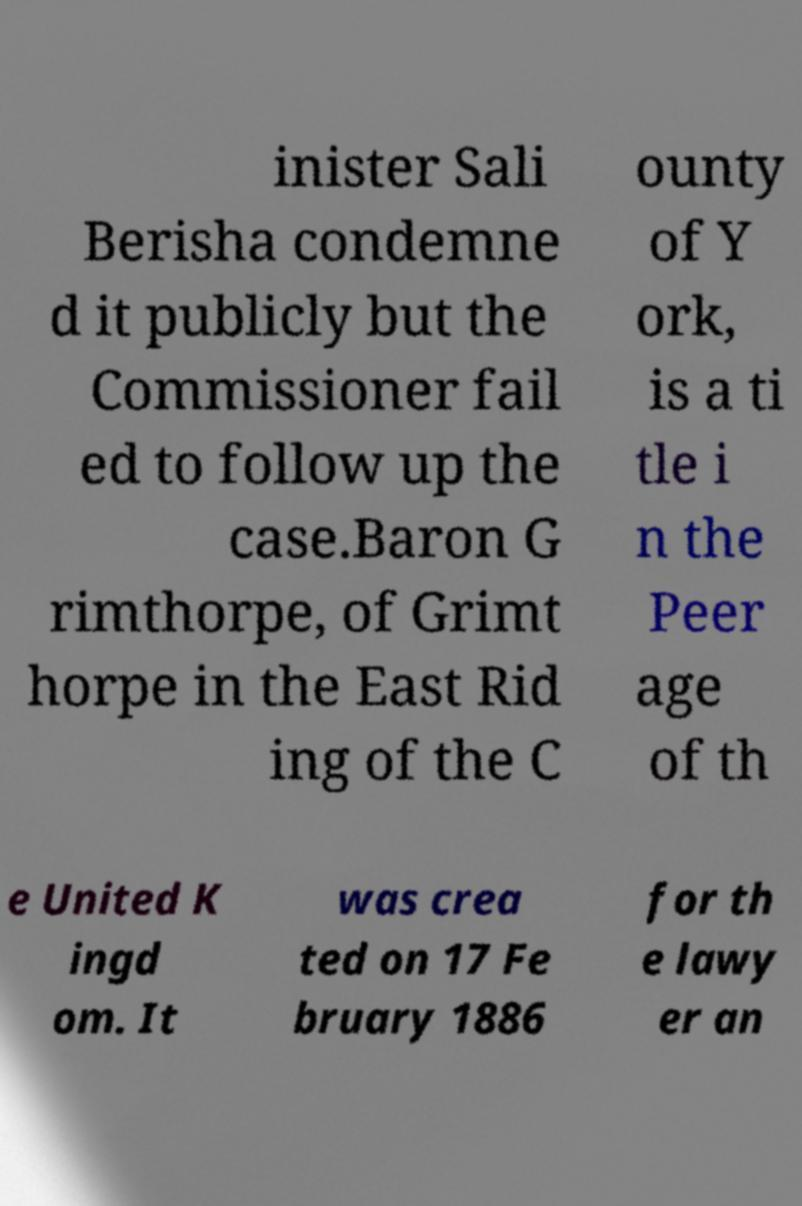There's text embedded in this image that I need extracted. Can you transcribe it verbatim? inister Sali Berisha condemne d it publicly but the Commissioner fail ed to follow up the case.Baron G rimthorpe, of Grimt horpe in the East Rid ing of the C ounty of Y ork, is a ti tle i n the Peer age of th e United K ingd om. It was crea ted on 17 Fe bruary 1886 for th e lawy er an 